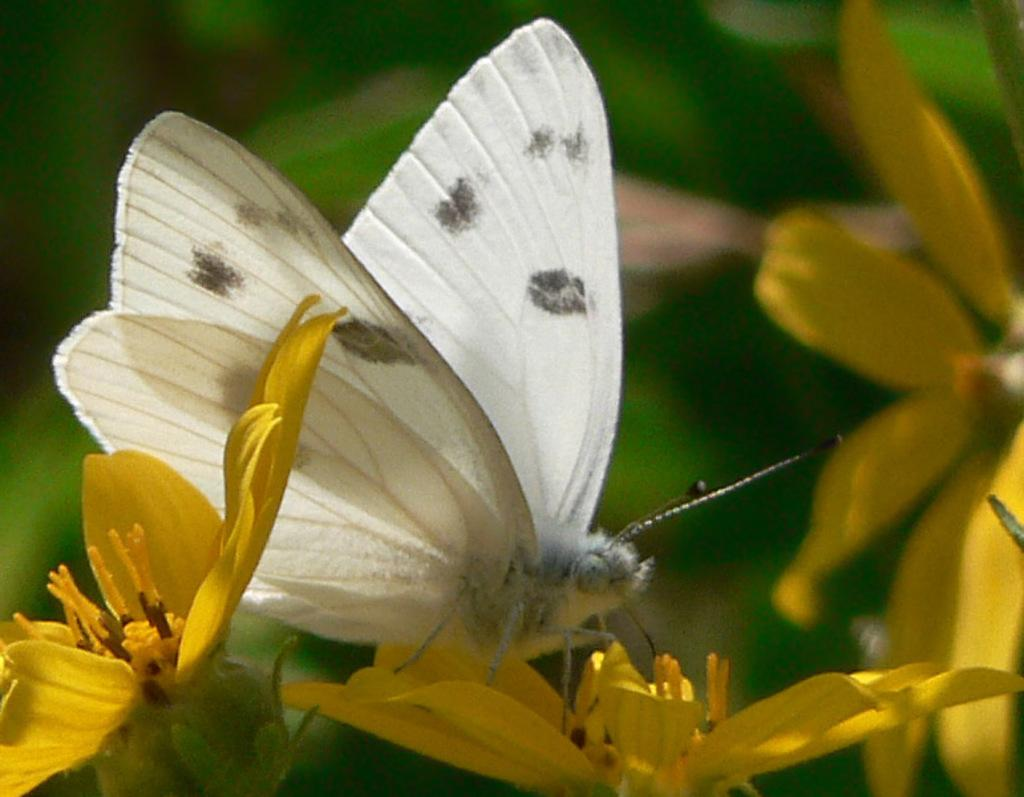What is on the flower in the image? There is a butterfly on a flower in the image. Can you describe the flower in the image? The flower has petals and pollen grains. What is the background of the image like? The background of the image is blurry. What type of mine can be seen in the image? There is no mine present in the image; it features a butterfly on a flower. What kind of meat is being served on the flower in the image? There is no meat present in the image; it features a butterfly on a flower. 